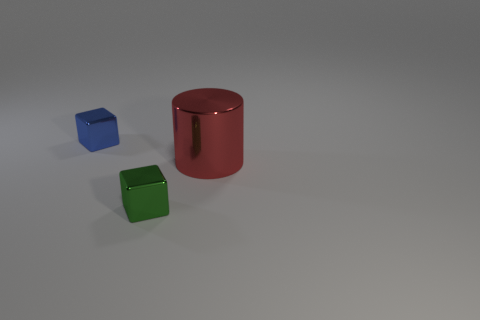Does the tiny blue object have the same material as the object that is in front of the big red thing?
Ensure brevity in your answer.  Yes. What is the shape of the thing that is both on the right side of the blue object and left of the red cylinder?
Ensure brevity in your answer.  Cube. What number of other objects are there of the same color as the metallic cylinder?
Provide a succinct answer. 0. What shape is the red metallic object?
Your answer should be compact. Cylinder. What color is the metal block behind the cylinder in front of the blue thing?
Keep it short and to the point. Blue. There is a large metallic object; does it have the same color as the small shiny cube in front of the small blue metal thing?
Give a very brief answer. No. There is a object that is both on the left side of the cylinder and in front of the small blue shiny object; what material is it?
Keep it short and to the point. Metal. Is there another red cylinder of the same size as the red shiny cylinder?
Keep it short and to the point. No. What material is the block that is the same size as the blue thing?
Your answer should be compact. Metal. There is a green cube; what number of small green things are in front of it?
Your response must be concise. 0. 